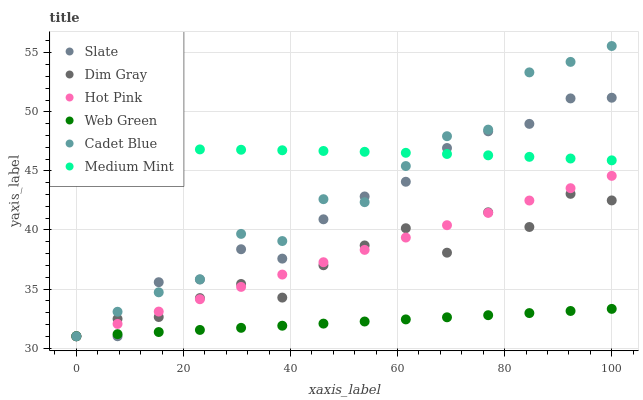Does Web Green have the minimum area under the curve?
Answer yes or no. Yes. Does Medium Mint have the maximum area under the curve?
Answer yes or no. Yes. Does Cadet Blue have the minimum area under the curve?
Answer yes or no. No. Does Cadet Blue have the maximum area under the curve?
Answer yes or no. No. Is Web Green the smoothest?
Answer yes or no. Yes. Is Dim Gray the roughest?
Answer yes or no. Yes. Is Cadet Blue the smoothest?
Answer yes or no. No. Is Cadet Blue the roughest?
Answer yes or no. No. Does Cadet Blue have the lowest value?
Answer yes or no. Yes. Does Cadet Blue have the highest value?
Answer yes or no. Yes. Does Slate have the highest value?
Answer yes or no. No. Is Hot Pink less than Medium Mint?
Answer yes or no. Yes. Is Medium Mint greater than Dim Gray?
Answer yes or no. Yes. Does Web Green intersect Cadet Blue?
Answer yes or no. Yes. Is Web Green less than Cadet Blue?
Answer yes or no. No. Is Web Green greater than Cadet Blue?
Answer yes or no. No. Does Hot Pink intersect Medium Mint?
Answer yes or no. No. 